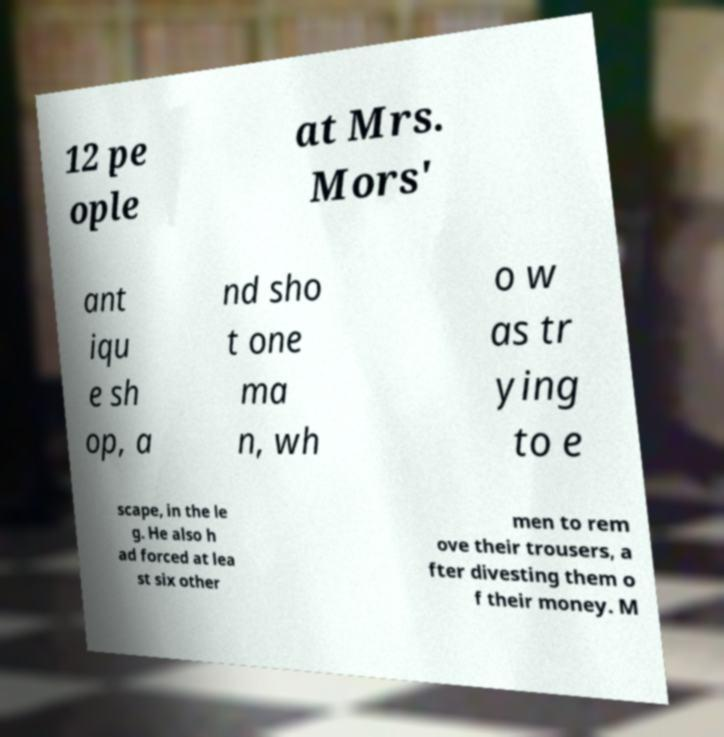Could you assist in decoding the text presented in this image and type it out clearly? 12 pe ople at Mrs. Mors' ant iqu e sh op, a nd sho t one ma n, wh o w as tr ying to e scape, in the le g. He also h ad forced at lea st six other men to rem ove their trousers, a fter divesting them o f their money. M 